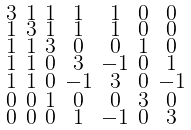Convert formula to latex. <formula><loc_0><loc_0><loc_500><loc_500>\begin{smallmatrix} 3 & 1 & 1 & 1 & 1 & 0 & 0 \\ 1 & 3 & 1 & 1 & 1 & 0 & 0 \\ 1 & 1 & 3 & 0 & 0 & 1 & 0 \\ 1 & 1 & 0 & 3 & - 1 & 0 & 1 \\ 1 & 1 & 0 & - 1 & 3 & 0 & - 1 \\ 0 & 0 & 1 & 0 & 0 & 3 & 0 \\ 0 & 0 & 0 & 1 & - 1 & 0 & 3 \end{smallmatrix}</formula> 